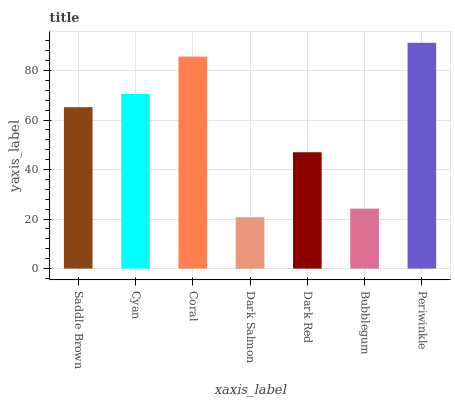Is Dark Salmon the minimum?
Answer yes or no. Yes. Is Periwinkle the maximum?
Answer yes or no. Yes. Is Cyan the minimum?
Answer yes or no. No. Is Cyan the maximum?
Answer yes or no. No. Is Cyan greater than Saddle Brown?
Answer yes or no. Yes. Is Saddle Brown less than Cyan?
Answer yes or no. Yes. Is Saddle Brown greater than Cyan?
Answer yes or no. No. Is Cyan less than Saddle Brown?
Answer yes or no. No. Is Saddle Brown the high median?
Answer yes or no. Yes. Is Saddle Brown the low median?
Answer yes or no. Yes. Is Dark Red the high median?
Answer yes or no. No. Is Periwinkle the low median?
Answer yes or no. No. 